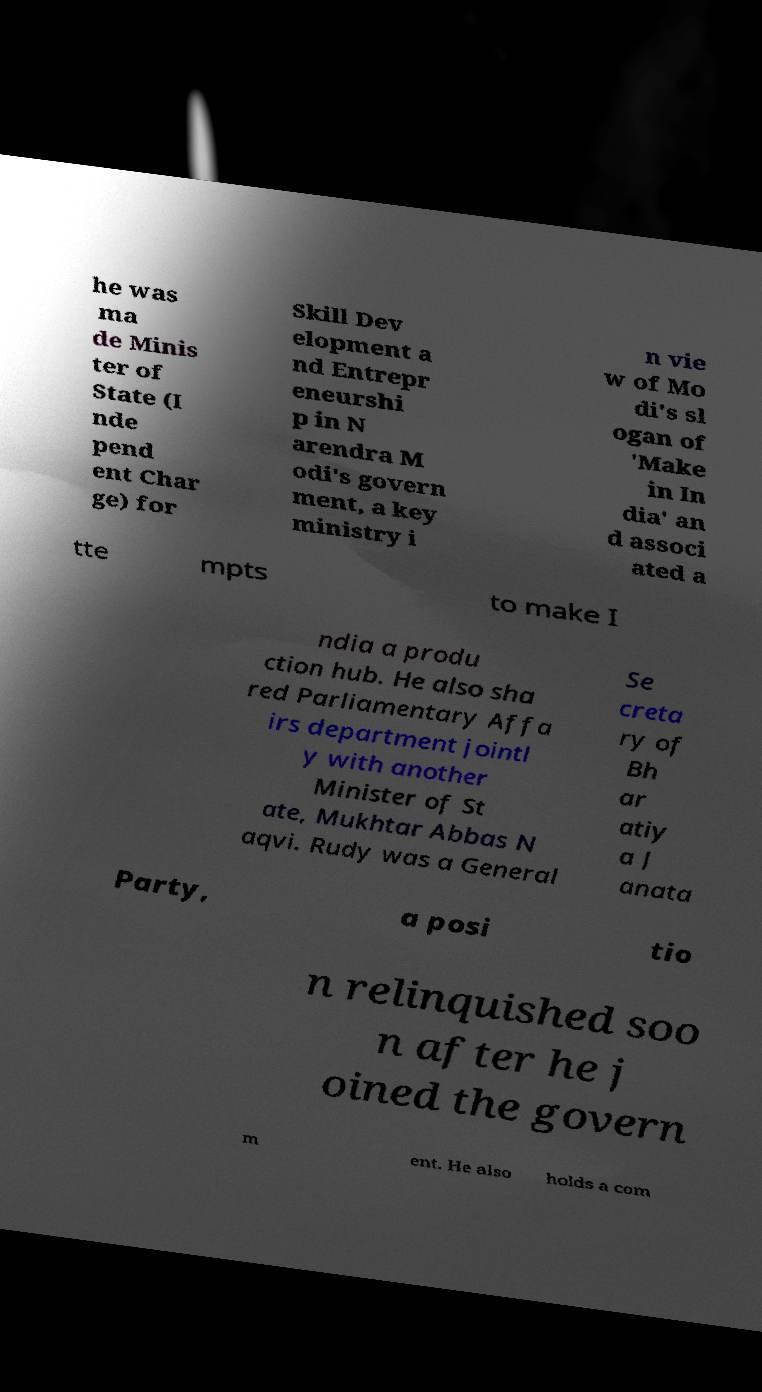What messages or text are displayed in this image? I need them in a readable, typed format. he was ma de Minis ter of State (I nde pend ent Char ge) for Skill Dev elopment a nd Entrepr eneurshi p in N arendra M odi's govern ment, a key ministry i n vie w of Mo di's sl ogan of 'Make in In dia' an d associ ated a tte mpts to make I ndia a produ ction hub. He also sha red Parliamentary Affa irs department jointl y with another Minister of St ate, Mukhtar Abbas N aqvi. Rudy was a General Se creta ry of Bh ar atiy a J anata Party, a posi tio n relinquished soo n after he j oined the govern m ent. He also holds a com 